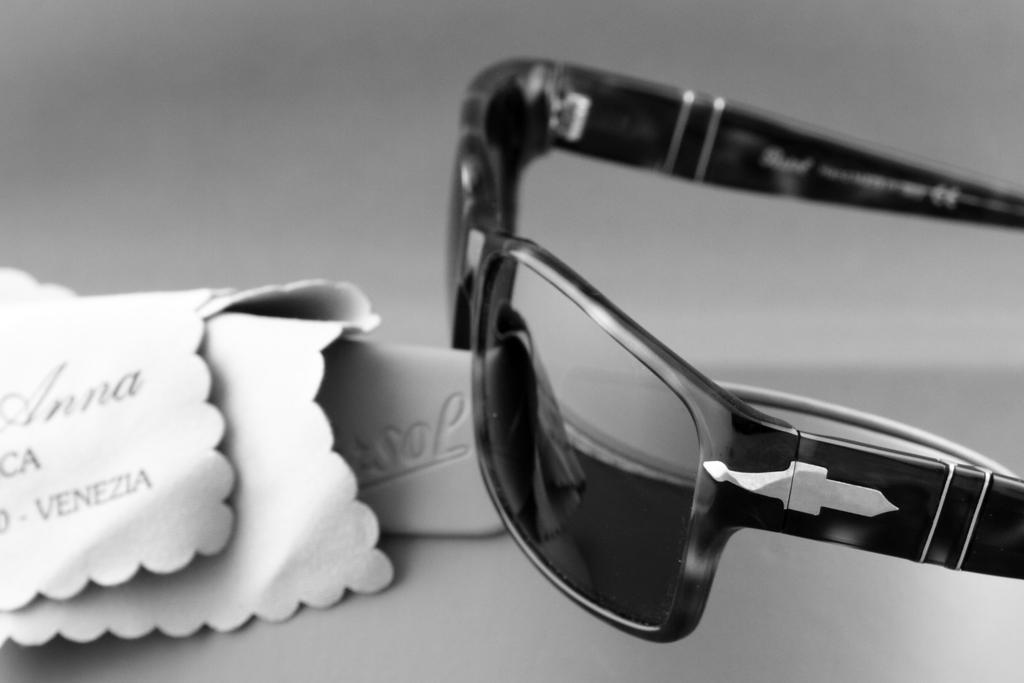Can you describe this image briefly? This is a black and white image. On the right side of the image we can see the goggles. On the left side of the image we can see the clothes and text. 